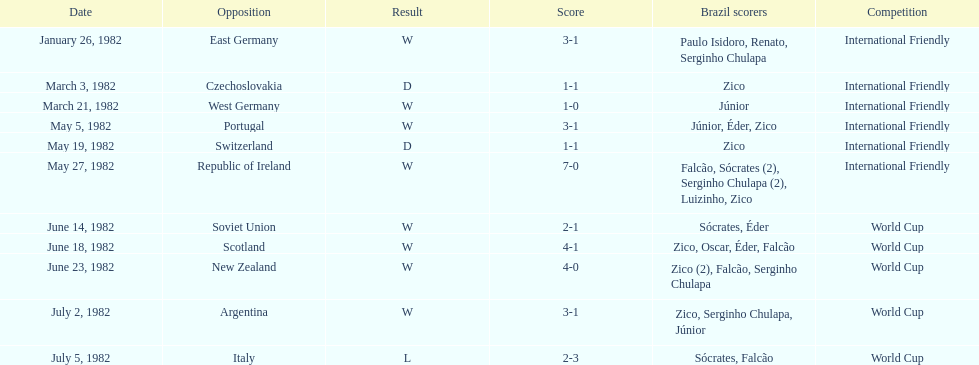Could you parse the entire table? {'header': ['Date', 'Opposition', 'Result', 'Score', 'Brazil scorers', 'Competition'], 'rows': [['January 26, 1982', 'East Germany', 'W', '3-1', 'Paulo Isidoro, Renato, Serginho Chulapa', 'International Friendly'], ['March 3, 1982', 'Czechoslovakia', 'D', '1-1', 'Zico', 'International Friendly'], ['March 21, 1982', 'West Germany', 'W', '1-0', 'Júnior', 'International Friendly'], ['May 5, 1982', 'Portugal', 'W', '3-1', 'Júnior, Éder, Zico', 'International Friendly'], ['May 19, 1982', 'Switzerland', 'D', '1-1', 'Zico', 'International Friendly'], ['May 27, 1982', 'Republic of Ireland', 'W', '7-0', 'Falcão, Sócrates (2), Serginho Chulapa (2), Luizinho, Zico', 'International Friendly'], ['June 14, 1982', 'Soviet Union', 'W', '2-1', 'Sócrates, Éder', 'World Cup'], ['June 18, 1982', 'Scotland', 'W', '4-1', 'Zico, Oscar, Éder, Falcão', 'World Cup'], ['June 23, 1982', 'New Zealand', 'W', '4-0', 'Zico (2), Falcão, Serginho Chulapa', 'World Cup'], ['July 2, 1982', 'Argentina', 'W', '3-1', 'Zico, Serginho Chulapa, Júnior', 'World Cup'], ['July 5, 1982', 'Italy', 'L', '2-3', 'Sócrates, Falcão', 'World Cup']]} How many games did this team play in 1982? 11. 